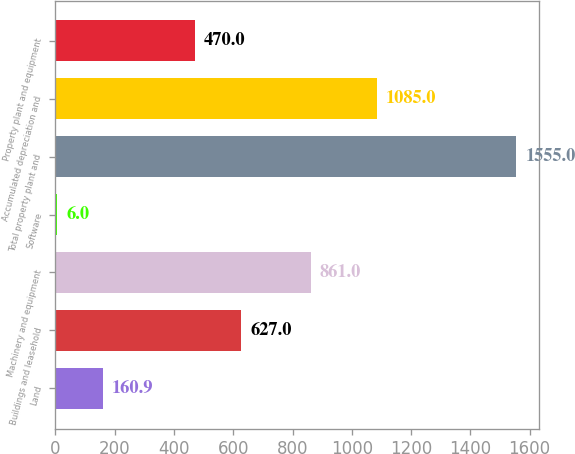Convert chart to OTSL. <chart><loc_0><loc_0><loc_500><loc_500><bar_chart><fcel>Land<fcel>Buildings and leasehold<fcel>Machinery and equipment<fcel>Software<fcel>Total property plant and<fcel>Accumulated depreciation and<fcel>Property plant and equipment<nl><fcel>160.9<fcel>627<fcel>861<fcel>6<fcel>1555<fcel>1085<fcel>470<nl></chart> 